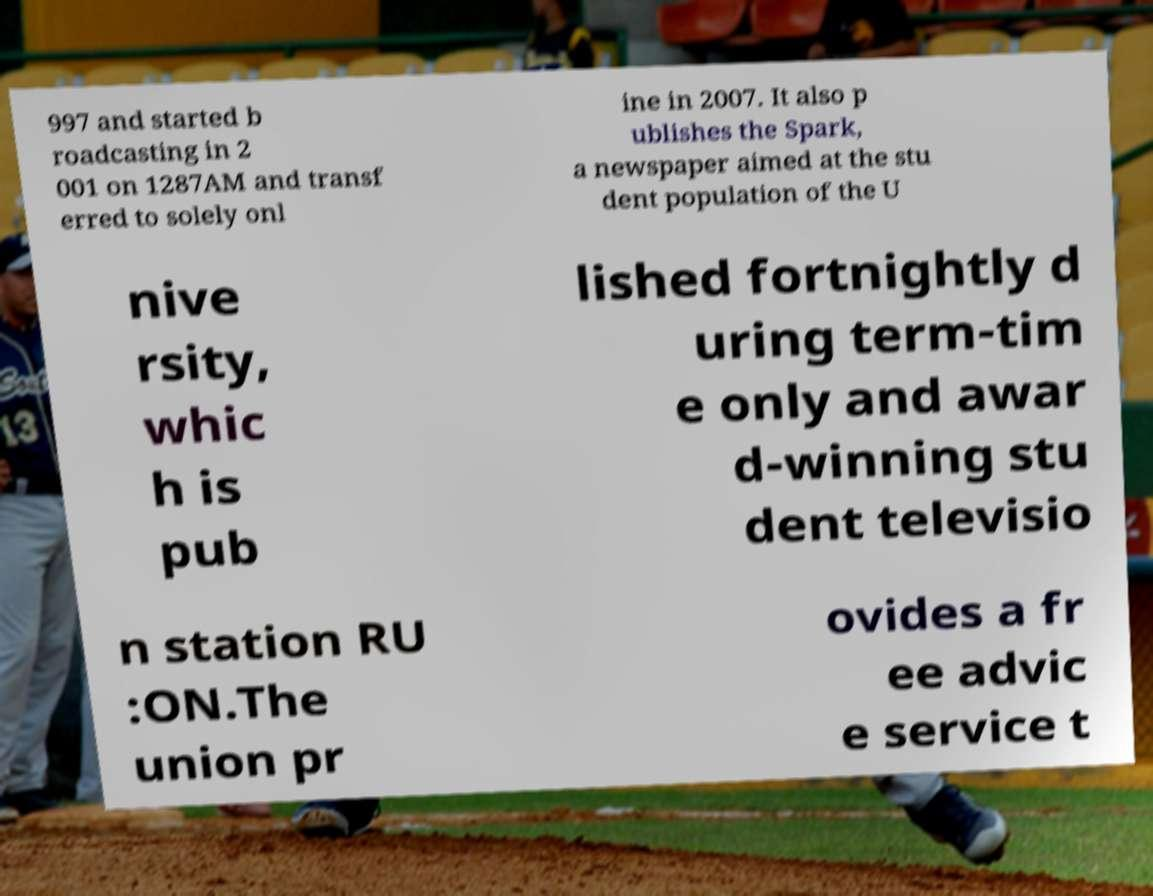Please identify and transcribe the text found in this image. 997 and started b roadcasting in 2 001 on 1287AM and transf erred to solely onl ine in 2007. It also p ublishes the Spark, a newspaper aimed at the stu dent population of the U nive rsity, whic h is pub lished fortnightly d uring term-tim e only and awar d-winning stu dent televisio n station RU :ON.The union pr ovides a fr ee advic e service t 